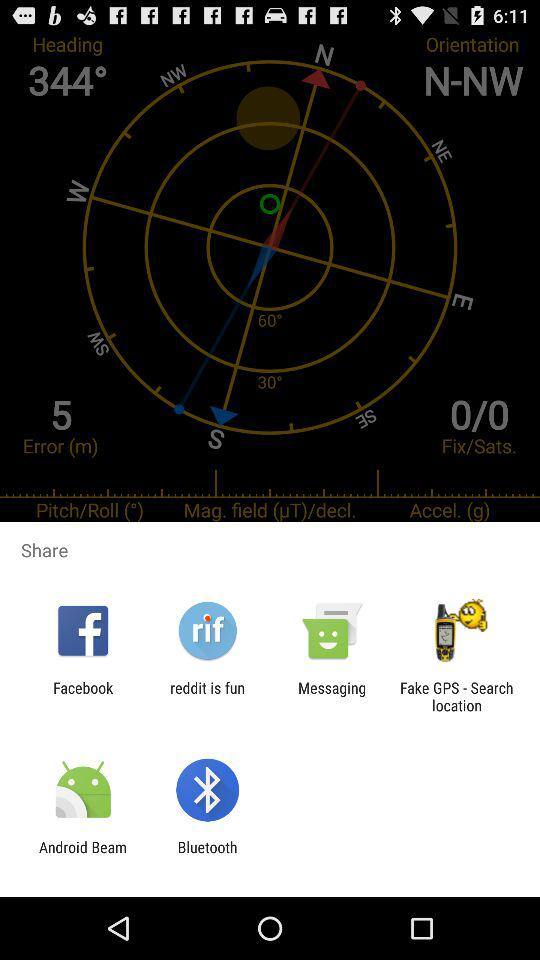Through which application can it be shared? It can be shared through "Facebook", "reddit is fun", "Messaging", "Fake GPS - Search location", "Android Beam" and "Bluetooth". 